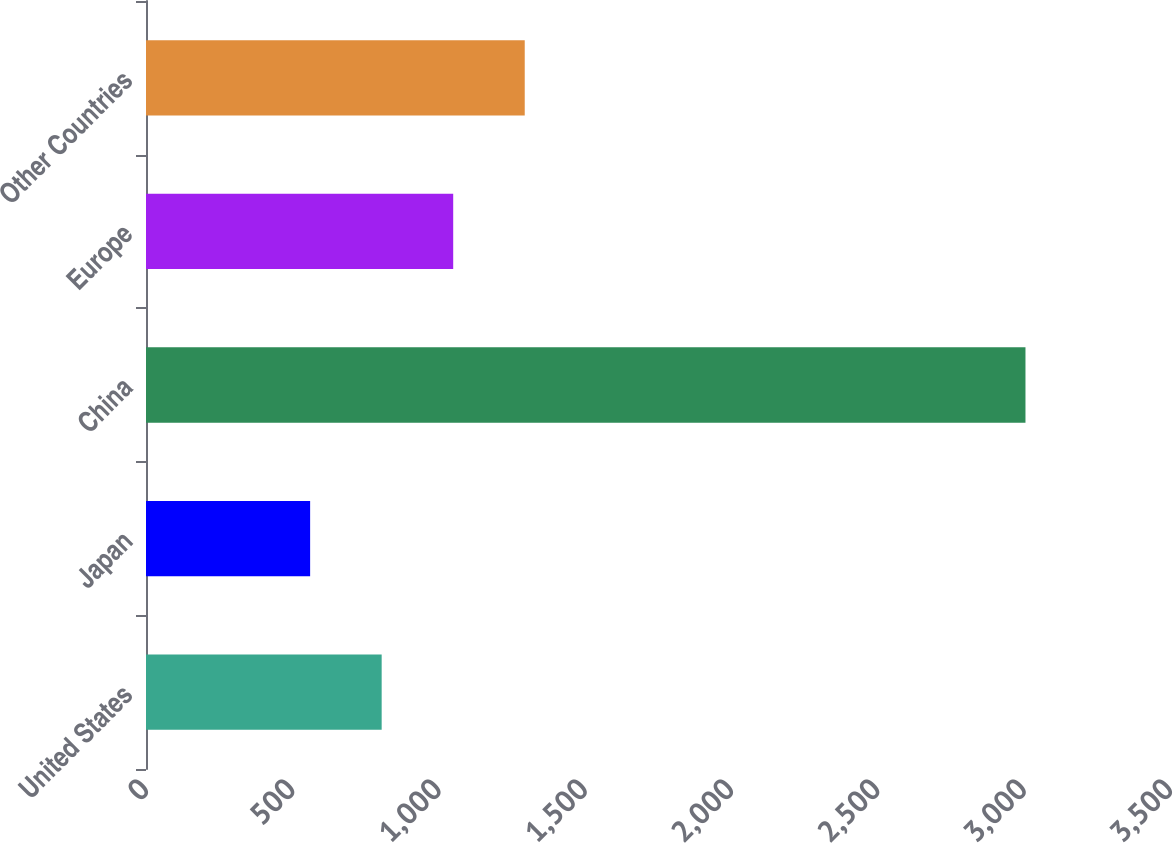Convert chart. <chart><loc_0><loc_0><loc_500><loc_500><bar_chart><fcel>United States<fcel>Japan<fcel>China<fcel>Europe<fcel>Other Countries<nl><fcel>805.5<fcel>561<fcel>3006<fcel>1050<fcel>1294.5<nl></chart> 